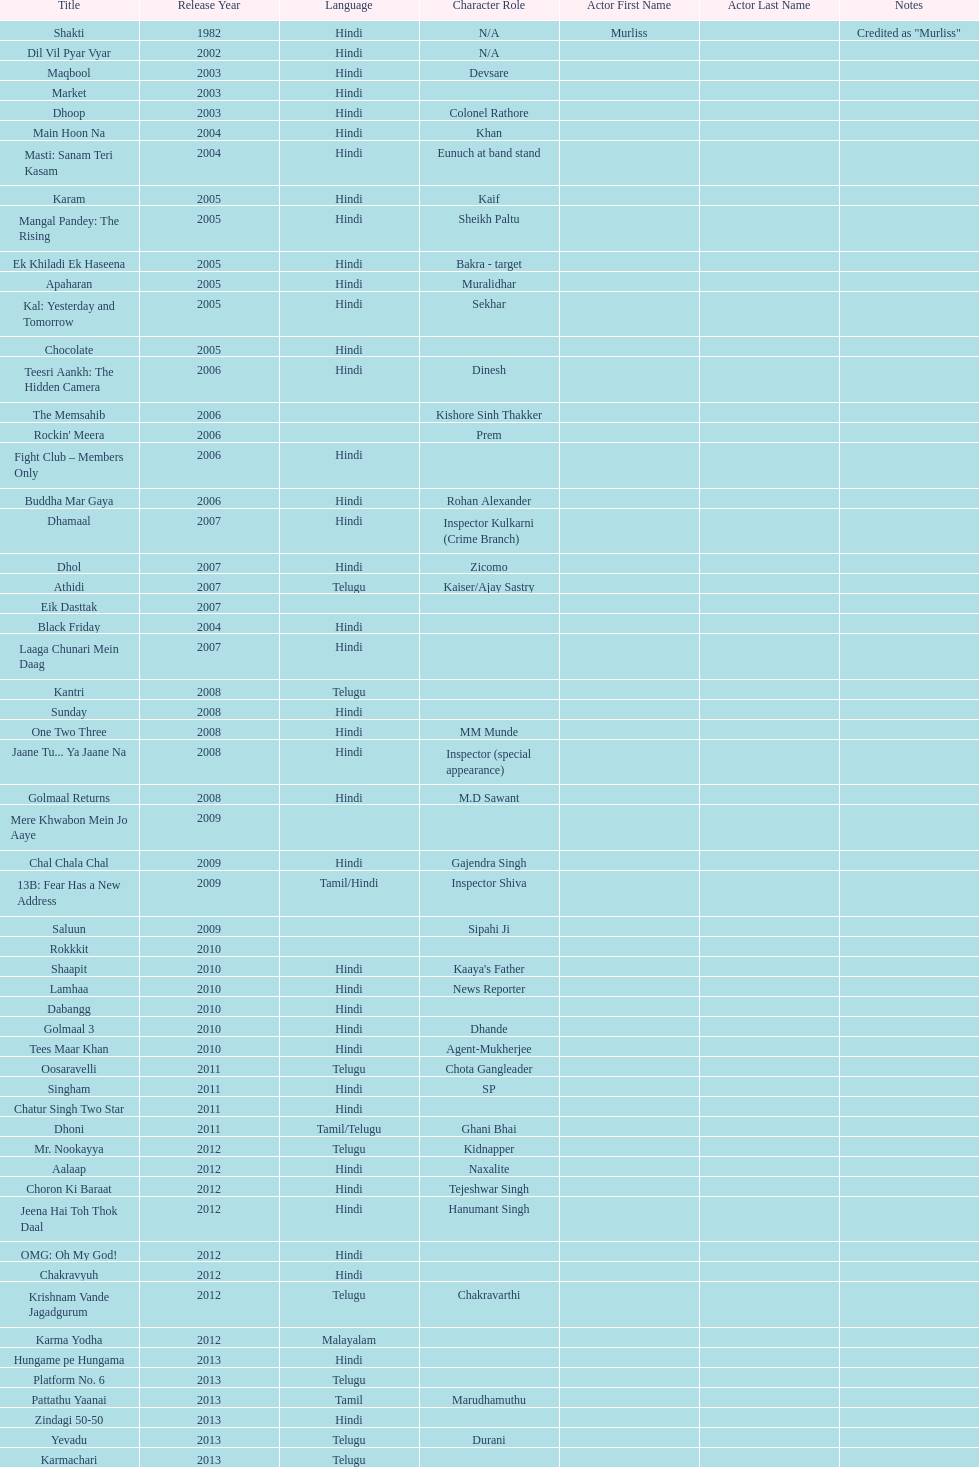Does maqbool have longer notes than shakti? No. Would you mind parsing the complete table? {'header': ['Title', 'Release Year', 'Language', 'Character Role', 'Actor First Name', 'Actor Last Name', 'Notes'], 'rows': [['Shakti', '1982', 'Hindi', 'N/A', 'Murliss', '', 'Credited as "Murliss"'], ['Dil Vil Pyar Vyar', '2002', 'Hindi', 'N/A', '', '', ''], ['Maqbool', '2003', 'Hindi', 'Devsare', '', '', ''], ['Market', '2003', 'Hindi', '', '', '', ''], ['Dhoop', '2003', 'Hindi', 'Colonel Rathore', '', '', ''], ['Main Hoon Na', '2004', 'Hindi', 'Khan', '', '', ''], ['Masti: Sanam Teri Kasam', '2004', 'Hindi', 'Eunuch at band stand', '', '', ''], ['Karam', '2005', 'Hindi', 'Kaif', '', '', ''], ['Mangal Pandey: The Rising', '2005', 'Hindi', 'Sheikh Paltu', '', '', ''], ['Ek Khiladi Ek Haseena', '2005', 'Hindi', 'Bakra - target', '', '', ''], ['Apaharan', '2005', 'Hindi', 'Muralidhar', '', '', ''], ['Kal: Yesterday and Tomorrow', '2005', 'Hindi', 'Sekhar', '', '', ''], ['Chocolate', '2005', 'Hindi', '', '', '', ''], ['Teesri Aankh: The Hidden Camera', '2006', 'Hindi', 'Dinesh', '', '', ''], ['The Memsahib', '2006', '', 'Kishore Sinh Thakker', '', '', ''], ["Rockin' Meera", '2006', '', 'Prem', '', '', ''], ['Fight Club – Members Only', '2006', 'Hindi', '', '', '', ''], ['Buddha Mar Gaya', '2006', 'Hindi', 'Rohan Alexander', '', '', ''], ['Dhamaal', '2007', 'Hindi', 'Inspector Kulkarni (Crime Branch)', '', '', ''], ['Dhol', '2007', 'Hindi', 'Zicomo', '', '', ''], ['Athidi', '2007', 'Telugu', 'Kaiser/Ajay Sastry', '', '', ''], ['Eik Dasttak', '2007', '', '', '', '', ''], ['Black Friday', '2004', 'Hindi', '', '', '', ''], ['Laaga Chunari Mein Daag', '2007', 'Hindi', '', '', '', ''], ['Kantri', '2008', 'Telugu', '', '', '', ''], ['Sunday', '2008', 'Hindi', '', '', '', ''], ['One Two Three', '2008', 'Hindi', 'MM Munde', '', '', ''], ['Jaane Tu... Ya Jaane Na', '2008', 'Hindi', 'Inspector (special appearance)', '', '', ''], ['Golmaal Returns', '2008', 'Hindi', 'M.D Sawant', '', '', ''], ['Mere Khwabon Mein Jo Aaye', '2009', '', '', '', '', ''], ['Chal Chala Chal', '2009', 'Hindi', 'Gajendra Singh', '', '', ''], ['13B: Fear Has a New Address', '2009', 'Tamil/Hindi', 'Inspector Shiva', '', '', ''], ['Saluun', '2009', '', 'Sipahi Ji', '', '', ''], ['Rokkkit', '2010', '', '', '', '', ''], ['Shaapit', '2010', 'Hindi', "Kaaya's Father", '', '', ''], ['Lamhaa', '2010', 'Hindi', 'News Reporter', '', '', ''], ['Dabangg', '2010', 'Hindi', '', '', '', ''], ['Golmaal 3', '2010', 'Hindi', 'Dhande', '', '', ''], ['Tees Maar Khan', '2010', 'Hindi', 'Agent-Mukherjee', '', '', ''], ['Oosaravelli', '2011', 'Telugu', 'Chota Gangleader', '', '', ''], ['Singham', '2011', 'Hindi', 'SP', '', '', ''], ['Chatur Singh Two Star', '2011', 'Hindi', '', '', '', ''], ['Dhoni', '2011', 'Tamil/Telugu', 'Ghani Bhai', '', '', ''], ['Mr. Nookayya', '2012', 'Telugu', 'Kidnapper', '', '', ''], ['Aalaap', '2012', 'Hindi', 'Naxalite', '', '', ''], ['Choron Ki Baraat', '2012', 'Hindi', 'Tejeshwar Singh', '', '', ''], ['Jeena Hai Toh Thok Daal', '2012', 'Hindi', 'Hanumant Singh', '', '', ''], ['OMG: Oh My God!', '2012', 'Hindi', '', '', '', ''], ['Chakravyuh', '2012', 'Hindi', '', '', '', ''], ['Krishnam Vande Jagadgurum', '2012', 'Telugu', 'Chakravarthi', '', '', ''], ['Karma Yodha', '2012', 'Malayalam', '', '', '', ''], ['Hungame pe Hungama', '2013', 'Hindi', '', '', '', ''], ['Platform No. 6', '2013', 'Telugu', '', '', '', ''], ['Pattathu Yaanai', '2013', 'Tamil', 'Marudhamuthu', '', '', ''], ['Zindagi 50-50', '2013', 'Hindi', '', '', '', ''], ['Yevadu', '2013', 'Telugu', 'Durani', '', '', ''], ['Karmachari', '2013', 'Telugu', '', '', '', '']]} 